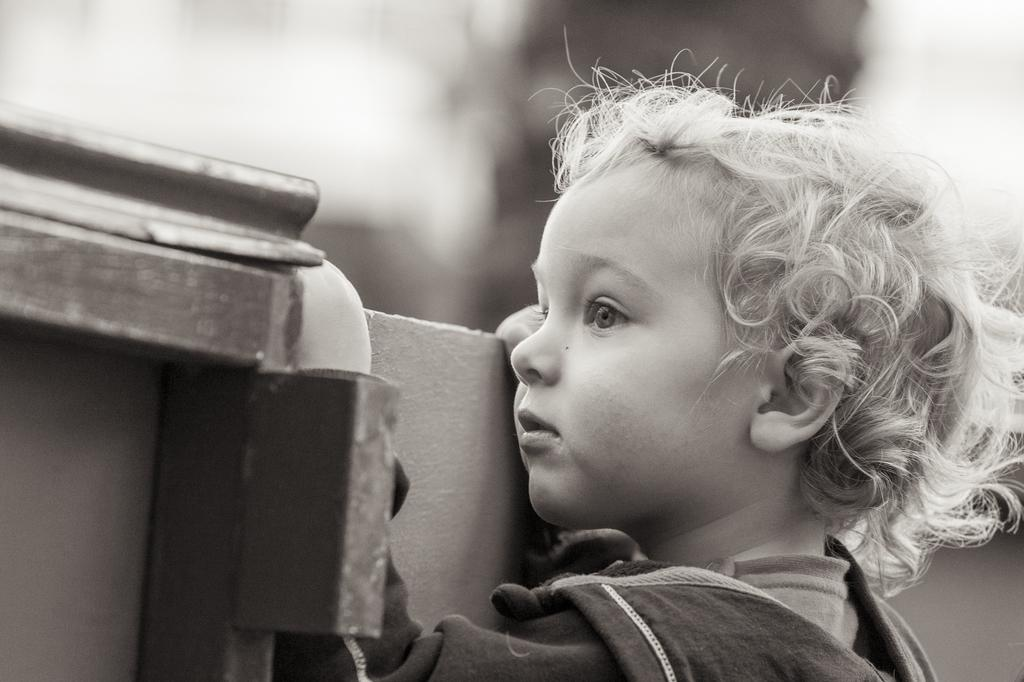What is the main subject of the image? The main subject of the image is a kid. Where is the kid positioned in the image? The kid is standing near a wall. What can be seen beside the kid? There are objects beside the kid. How would you describe the background of the image? The background of the image is blurry. What color is the paint the kid is using to twist in the image? There is no paint or twisting activity present in the image. 